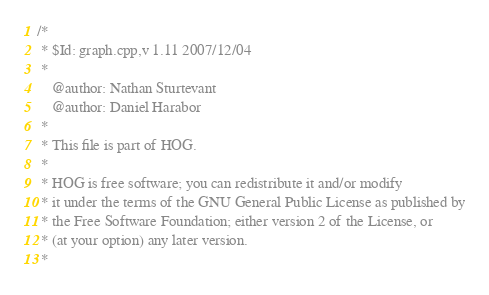<code> <loc_0><loc_0><loc_500><loc_500><_C++_>/*
 * $Id: graph.cpp,v 1.11 2007/12/04
 *
	@author: Nathan Sturtevant
	@author: Daniel Harabor
 * 
 * This file is part of HOG.
 *
 * HOG is free software; you can redistribute it and/or modify
 * it under the terms of the GNU General Public License as published by
 * the Free Software Foundation; either version 2 of the License, or
 * (at your option) any later version.
 * </code> 